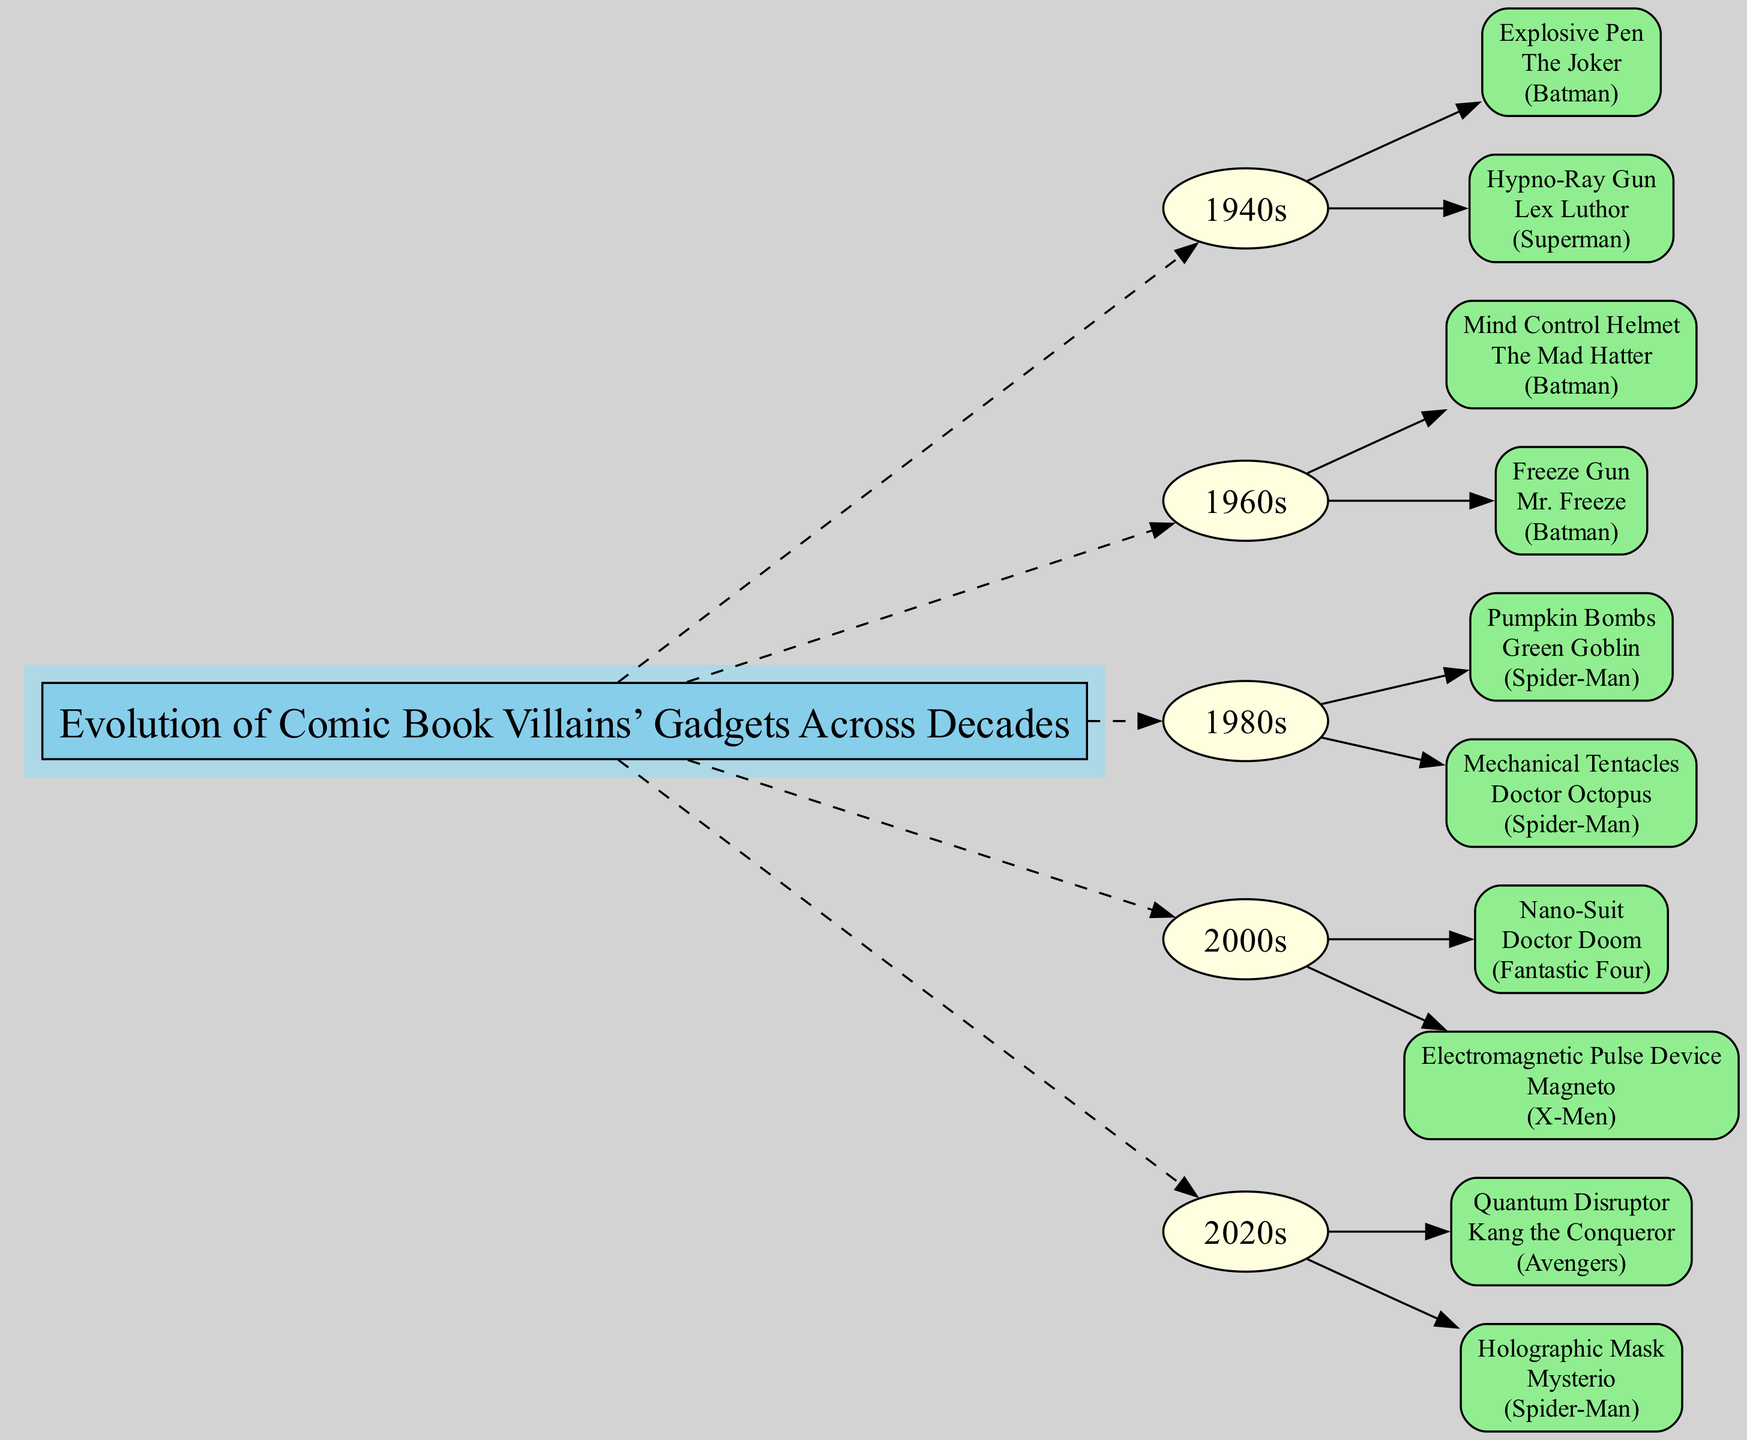What gadgets are associated with The Joker? The diagram shows that the gadgets associated with The Joker are listed under the 1940s section, specifically the "Explosive Pen".
Answer: Explosive Pen How many gadgets did villains use in the 1960s? By looking at the 1960s decade node, there are two gadgets listed: "Mind Control Helmet" and "Freeze Gun".
Answer: 2 Which villain uses the "Nano-Suit"? The "Nano-Suit" is mentioned in the 2000s section, and is associated with the villain "Doctor Doom" according to the corresponding node.
Answer: Doctor Doom What is the name of the gadget used by Mr. Freeze? The diagram indicates that Mr. Freeze's gadget is "Freeze Gun", which is noted in the gadgets list of the 1960s.
Answer: Freeze Gun Which decade introduced the "Pumpkin Bombs"? The "Pumpkin Bombs" gadget is shown under the 1980s section of the diagram, linked to the villain Green Goblin.
Answer: 1980s How many total decades are represented in the diagram? Counting the decades listed, there are five sections: 1940s, 1960s, 1980s, 2000s, and 2020s.
Answer: 5 What is the relationship between Kang the Conqueror and the "Quantum Disruptor"? The diagram shows that Kang the Conqueror is the villain associated with the "Quantum Disruptor" gadget listed in the 2020s section.
Answer: Villain to gadget Which gadgets are linked to Spider-Man comics? The diagram includes "Mechanical Tentacles" by Doctor Octopus and "Holographic Mask" by Mysterio, both explicitly connected to Spider-Man comics.
Answer: Mechanical Tentacles, Holographic Mask What gadget does Lex Luthor use in the 1940s? According to the diagram, Lex Luthor uses the "Hypno-Ray Gun", which is listed under the 1940s gadgets.
Answer: Hypno-Ray Gun 